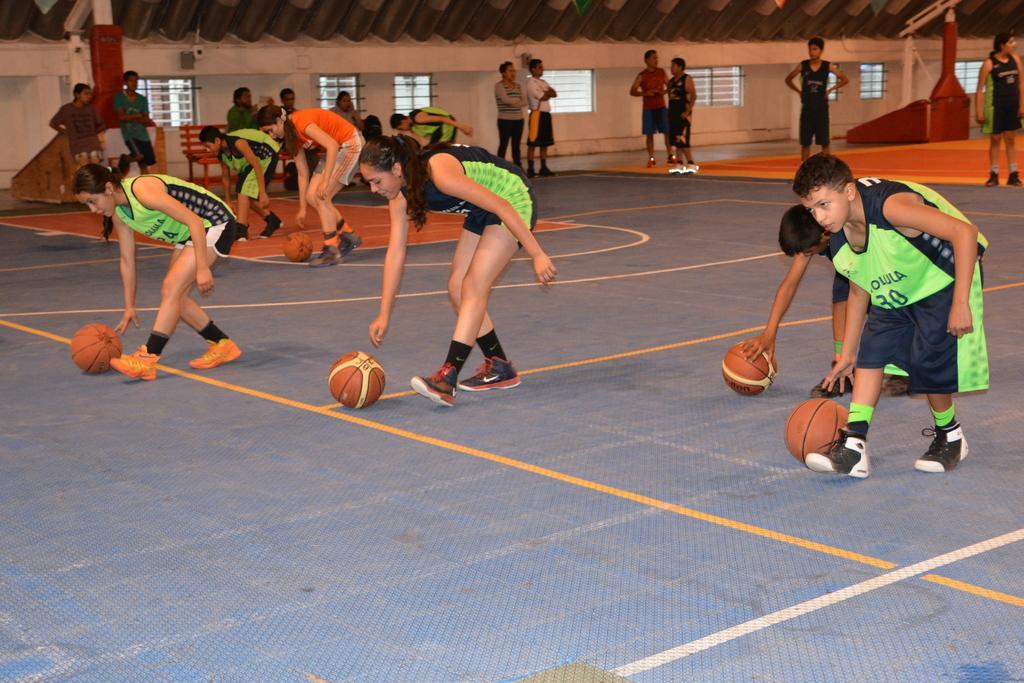How would you summarize this image in a sentence or two? In this image I can see some people standing together holding the ball on floor, beside them there are another group of people standing under the tent. 